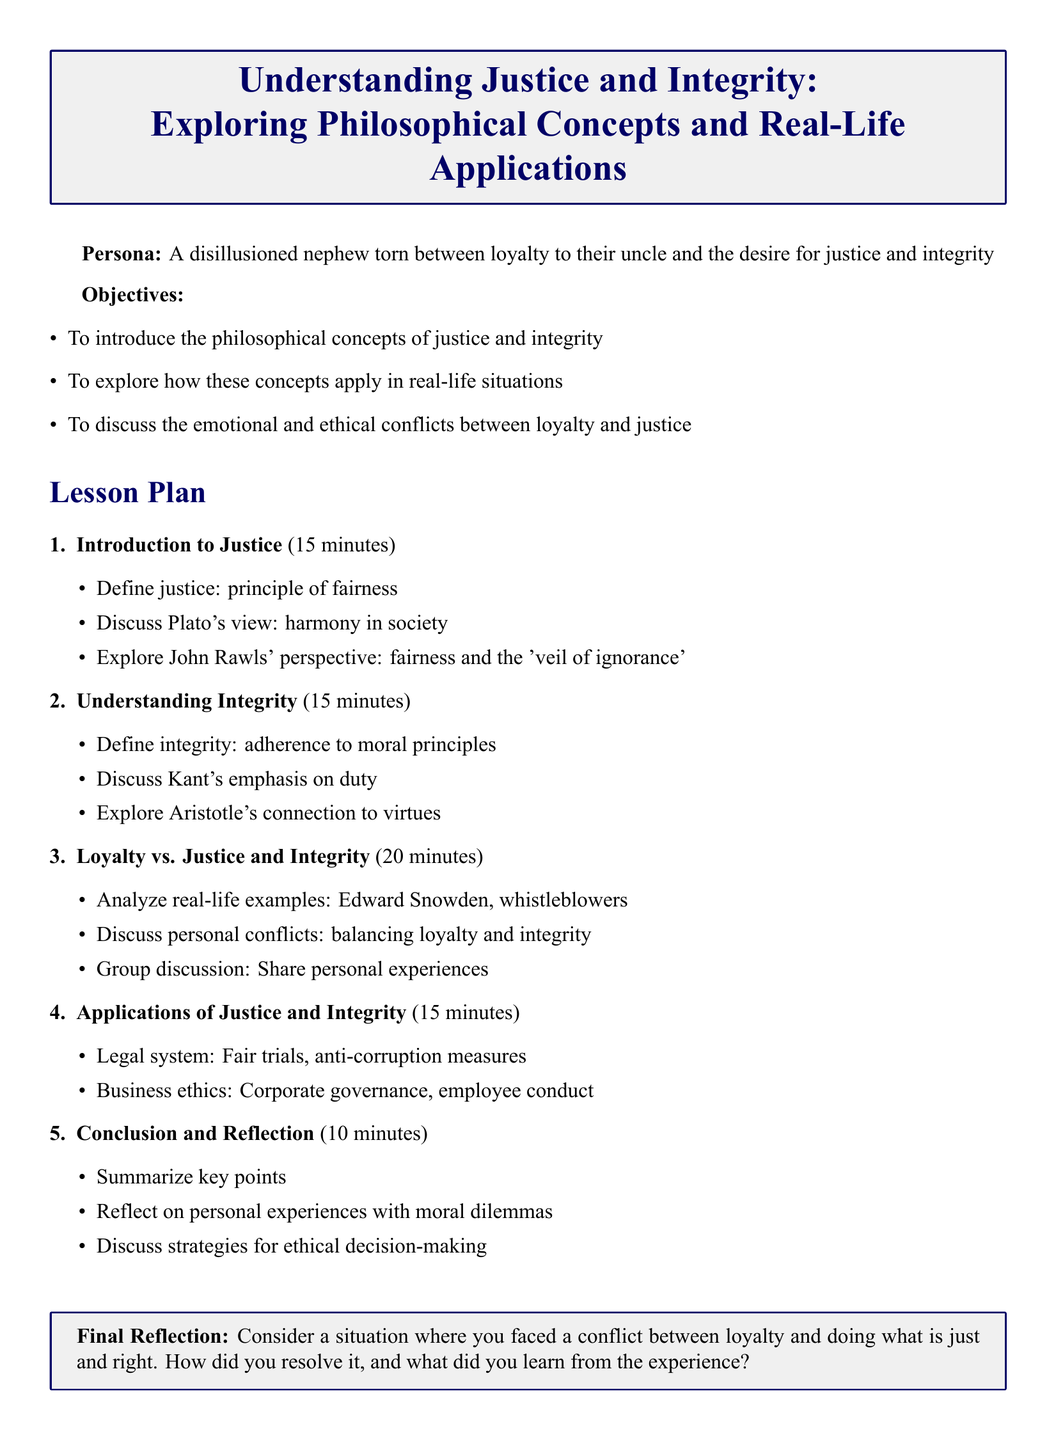What are the main objectives of the lesson plan? The main objectives include introducing philosophical concepts of justice and integrity, exploring real-life applications, and discussing emotional and ethical conflicts.
Answer: To introduce the philosophical concepts of justice and integrity, to explore how these concepts apply in real-life situations, to discuss the emotional and ethical conflicts between loyalty and justice What is the duration of the 'Loyalty vs. Justice and Integrity' section? The duration is clearly stated in the lesson plan as part of the structure, indicating the time allocated for this topic.
Answer: 20 minutes Who is associated with the 'veil of ignorance' concept? The veil of ignorance is a concept attributed to a specific philosopher discussed in the lesson plan, highlighting their contributions to the idea of fairness.
Answer: John Rawls How does Aristotle's view relate to integrity? Aristotle's view on integrity is mentioned within the context of the specific section focused on integrity, establishing his connection to moral principles.
Answer: Connection to virtues What is the focus of the final reflection in the lesson plan? The final reflection prompts learners to contemplate their personal experiences with ethical dilemmas, encouraging introspection and insights from their life.
Answer: Conflict between loyalty and doing what is just and right 